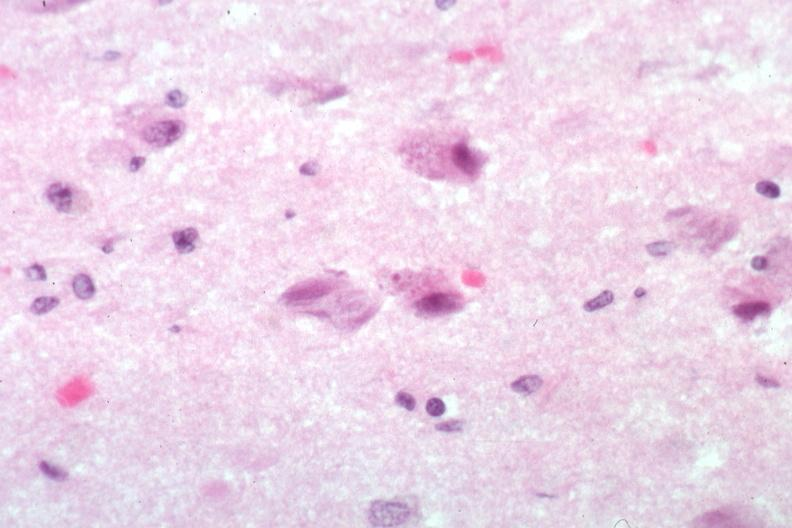what is present?
Answer the question using a single word or phrase. Neurofibrillary change 